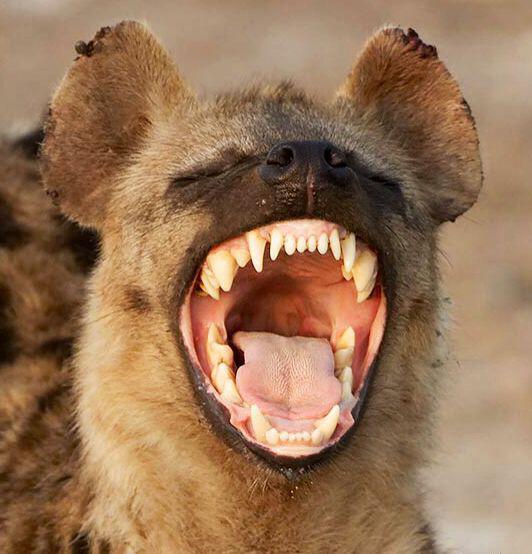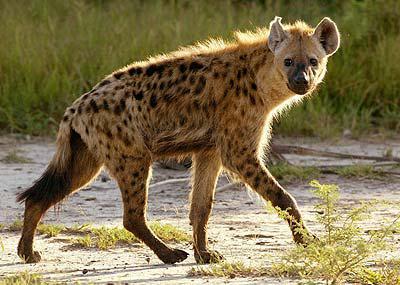The first image is the image on the left, the second image is the image on the right. Examine the images to the left and right. Is the description "Only one animal has its mouth open wide showing its teeth and tongue." accurate? Answer yes or no. Yes. The first image is the image on the left, the second image is the image on the right. Given the left and right images, does the statement "Only one image shows a hyena with mouth agape showing tongue and teeth." hold true? Answer yes or no. Yes. 